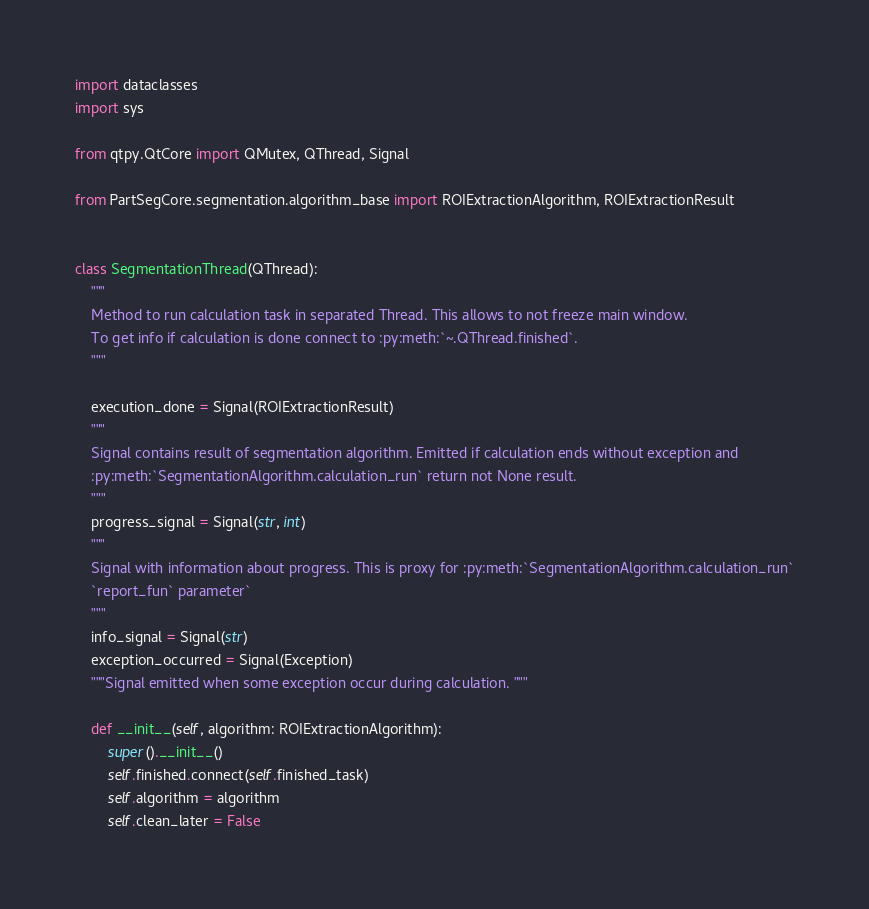Convert code to text. <code><loc_0><loc_0><loc_500><loc_500><_Python_>import dataclasses
import sys

from qtpy.QtCore import QMutex, QThread, Signal

from PartSegCore.segmentation.algorithm_base import ROIExtractionAlgorithm, ROIExtractionResult


class SegmentationThread(QThread):
    """
    Method to run calculation task in separated Thread. This allows to not freeze main window.
    To get info if calculation is done connect to :py:meth:`~.QThread.finished`.
    """

    execution_done = Signal(ROIExtractionResult)
    """
    Signal contains result of segmentation algorithm. Emitted if calculation ends without exception and
    :py:meth:`SegmentationAlgorithm.calculation_run` return not None result.
    """
    progress_signal = Signal(str, int)
    """
    Signal with information about progress. This is proxy for :py:meth:`SegmentationAlgorithm.calculation_run`
    `report_fun` parameter`
    """
    info_signal = Signal(str)
    exception_occurred = Signal(Exception)
    """Signal emitted when some exception occur during calculation. """

    def __init__(self, algorithm: ROIExtractionAlgorithm):
        super().__init__()
        self.finished.connect(self.finished_task)
        self.algorithm = algorithm
        self.clean_later = False</code> 